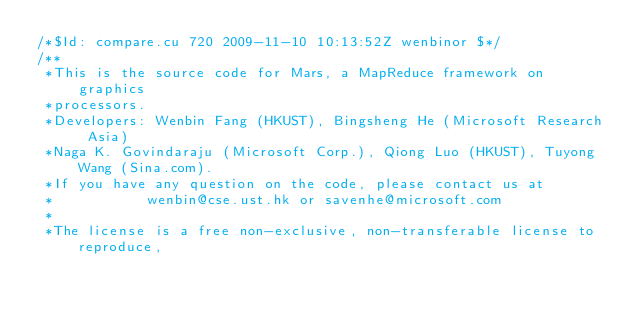Convert code to text. <code><loc_0><loc_0><loc_500><loc_500><_Cuda_>/*$Id: compare.cu 720 2009-11-10 10:13:52Z wenbinor $*/
/**
 *This is the source code for Mars, a MapReduce framework on graphics
 *processors.
 *Developers: Wenbin Fang (HKUST), Bingsheng He (Microsoft Research Asia)
 *Naga K. Govindaraju (Microsoft Corp.), Qiong Luo (HKUST), Tuyong Wang (Sina.com).
 *If you have any question on the code, please contact us at 
 *           wenbin@cse.ust.hk or savenhe@microsoft.com
 *
 *The license is a free non-exclusive, non-transferable license to reproduce, </code> 